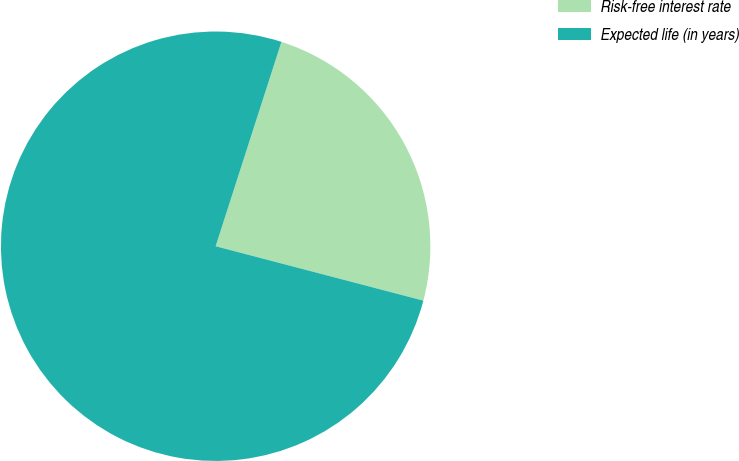Convert chart. <chart><loc_0><loc_0><loc_500><loc_500><pie_chart><fcel>Risk-free interest rate<fcel>Expected life (in years)<nl><fcel>24.12%<fcel>75.88%<nl></chart> 